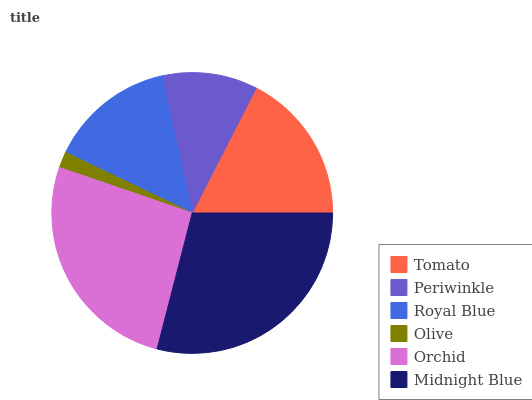Is Olive the minimum?
Answer yes or no. Yes. Is Midnight Blue the maximum?
Answer yes or no. Yes. Is Periwinkle the minimum?
Answer yes or no. No. Is Periwinkle the maximum?
Answer yes or no. No. Is Tomato greater than Periwinkle?
Answer yes or no. Yes. Is Periwinkle less than Tomato?
Answer yes or no. Yes. Is Periwinkle greater than Tomato?
Answer yes or no. No. Is Tomato less than Periwinkle?
Answer yes or no. No. Is Tomato the high median?
Answer yes or no. Yes. Is Royal Blue the low median?
Answer yes or no. Yes. Is Olive the high median?
Answer yes or no. No. Is Orchid the low median?
Answer yes or no. No. 